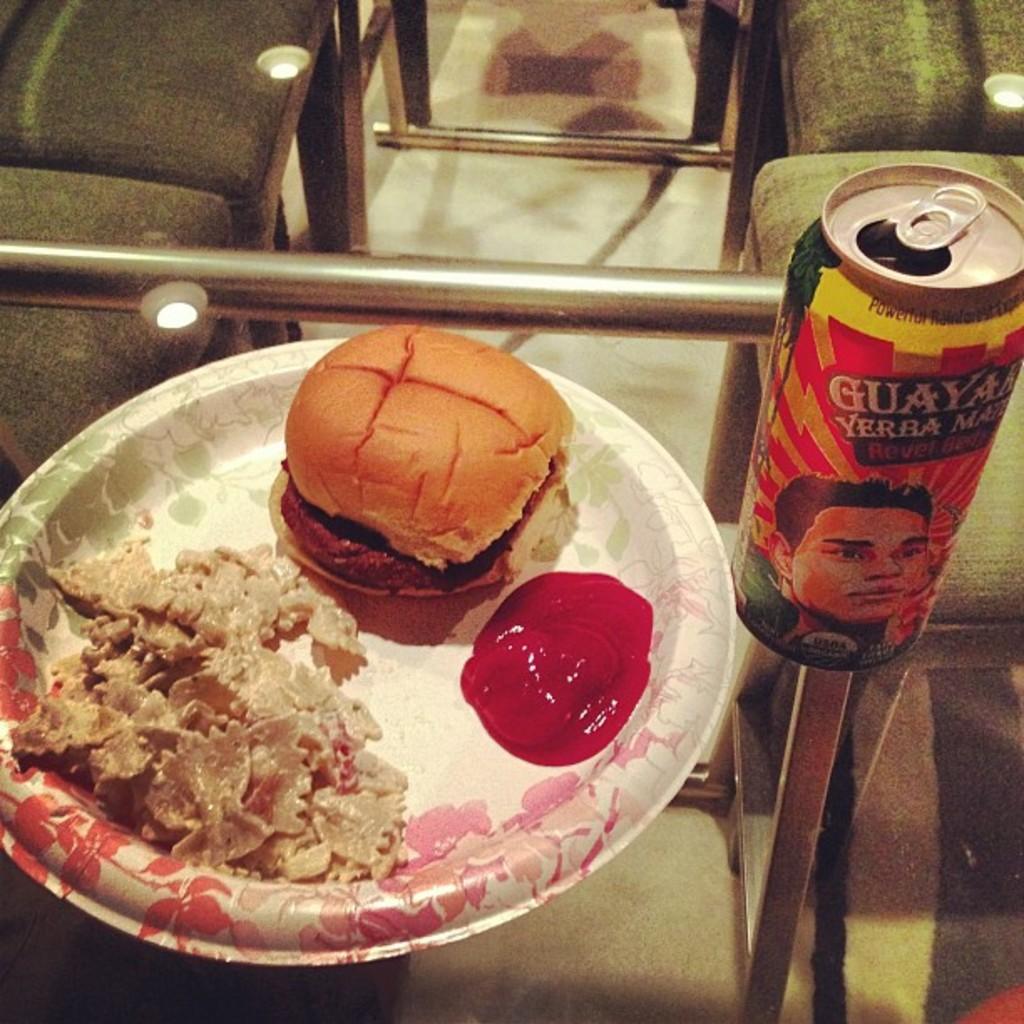Can you describe this image briefly? In this image I can see few food items, they are in brown, cream and red color, and the food is in the plate. The plate is in red and white color, and I can also see a tin. The plate and the tin is on the glass table. 